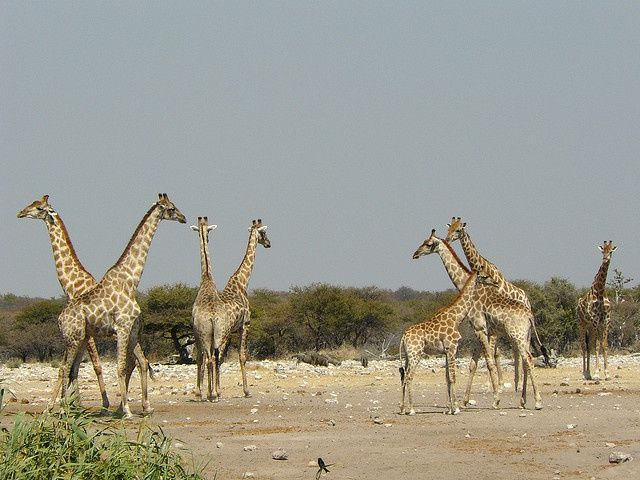Describe the objects in this image and their specific colors. I can see giraffe in darkgray, tan, olive, khaki, and gray tones, giraffe in darkgray, tan, and olive tones, giraffe in darkgray, tan, gray, khaki, and olive tones, giraffe in darkgray, tan, khaki, and olive tones, and giraffe in darkgray, tan, olive, and gray tones in this image. 